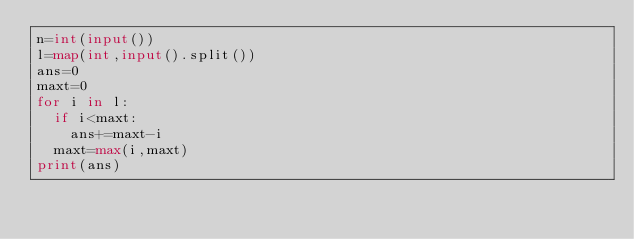<code> <loc_0><loc_0><loc_500><loc_500><_Python_>n=int(input())
l=map(int,input().split())
ans=0
maxt=0
for i in l:
  if i<maxt:
    ans+=maxt-i
  maxt=max(i,maxt)
print(ans)
</code> 